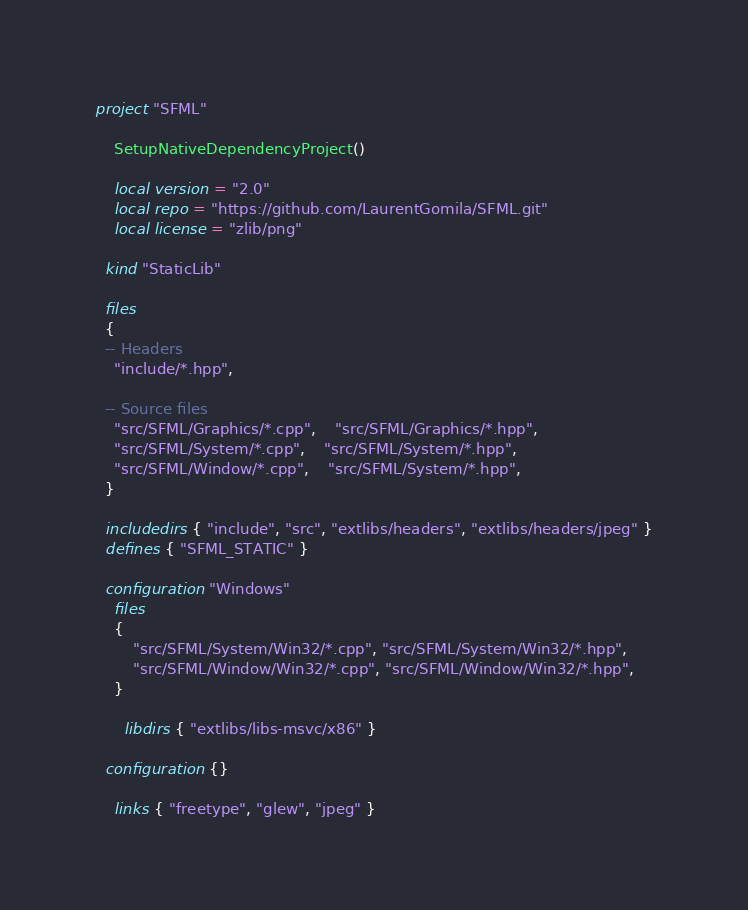<code> <loc_0><loc_0><loc_500><loc_500><_Lua_>project "SFML"

	SetupNativeDependencyProject()
		
	local version = "2.0"
	local repo = "https://github.com/LaurentGomila/SFML.git"
	local license = "zlib/png"
	
  kind "StaticLib"
  
  files
  {
  -- Headers
  	"include/*.hpp",

  -- Source files
  	"src/SFML/Graphics/*.cpp",	"src/SFML/Graphics/*.hpp",
  	"src/SFML/System/*.cpp",	"src/SFML/System/*.hpp",
  	"src/SFML/Window/*.cpp", 	"src/SFML/System/*.hpp",
  }
  
  includedirs { "include", "src", "extlibs/headers", "extlibs/headers/jpeg" }
  defines { "SFML_STATIC" }

  configuration "Windows"
  	files
  	{
  		"src/SFML/System/Win32/*.cpp", "src/SFML/System/Win32/*.hpp",
  		"src/SFML/Window/Win32/*.cpp", "src/SFML/Window/Win32/*.hpp",
  	}
    
	  libdirs { "extlibs/libs-msvc/x86" }
  
  configuration {}

	links { "freetype", "glew", "jpeg" }
</code> 